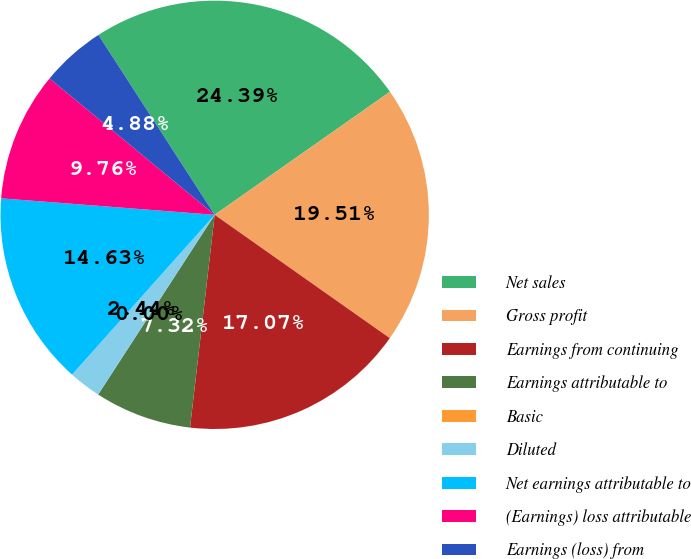Convert chart. <chart><loc_0><loc_0><loc_500><loc_500><pie_chart><fcel>Net sales<fcel>Gross profit<fcel>Earnings from continuing<fcel>Earnings attributable to<fcel>Basic<fcel>Diluted<fcel>Net earnings attributable to<fcel>(Earnings) loss attributable<fcel>Earnings (loss) from<nl><fcel>24.39%<fcel>19.51%<fcel>17.07%<fcel>7.32%<fcel>0.0%<fcel>2.44%<fcel>14.63%<fcel>9.76%<fcel>4.88%<nl></chart> 